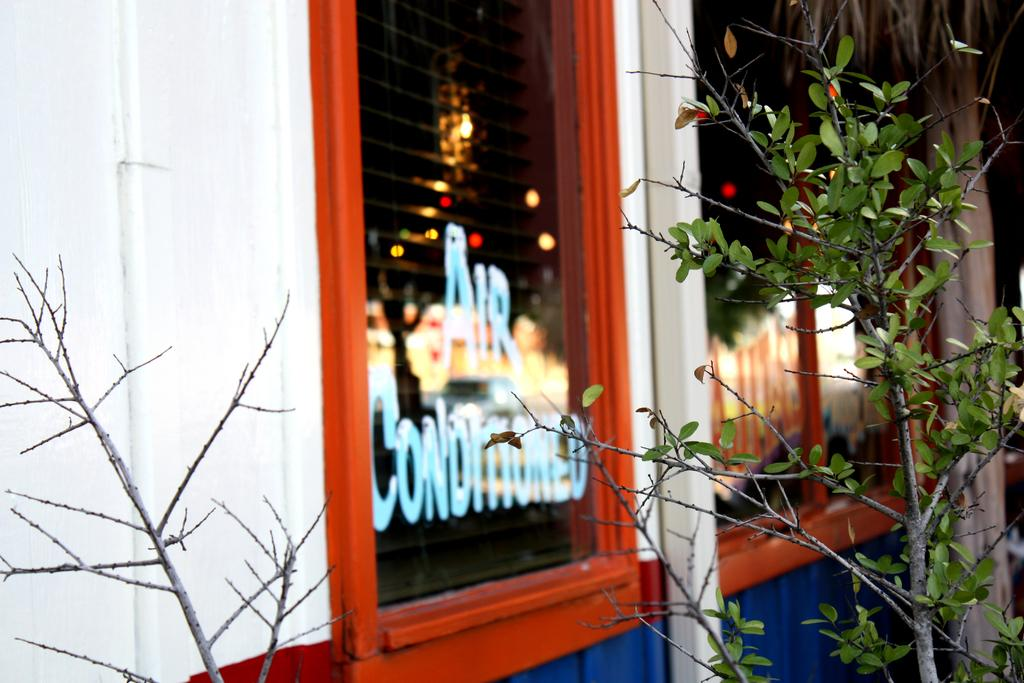What type of vegetation is on the right side of the image? There is a plant on the right side of the image. What can be seen on the left side of the image? There are glass windows on the left side of the image. What part of a tree is visible on the right side of the image? The trunk of a tree is visible on the right side of the image. How does the plant contribute to the increase in oxygen levels in the image? The image does not provide information about the plant's contribution to oxygen levels, nor does it show any changes in oxygen levels. 